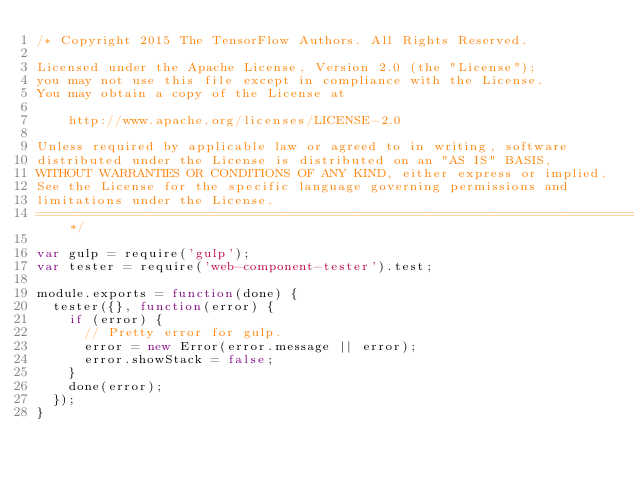<code> <loc_0><loc_0><loc_500><loc_500><_JavaScript_>/* Copyright 2015 The TensorFlow Authors. All Rights Reserved.

Licensed under the Apache License, Version 2.0 (the "License");
you may not use this file except in compliance with the License.
You may obtain a copy of the License at

    http://www.apache.org/licenses/LICENSE-2.0

Unless required by applicable law or agreed to in writing, software
distributed under the License is distributed on an "AS IS" BASIS,
WITHOUT WARRANTIES OR CONDITIONS OF ANY KIND, either express or implied.
See the License for the specific language governing permissions and
limitations under the License.
==============================================================================*/

var gulp = require('gulp');
var tester = require('web-component-tester').test;

module.exports = function(done) {
  tester({}, function(error) {
    if (error) {
      // Pretty error for gulp.
      error = new Error(error.message || error);
      error.showStack = false;
    }
    done(error);
  });
}
</code> 